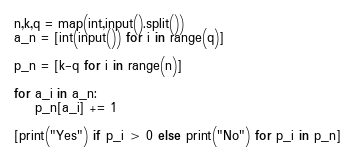<code> <loc_0><loc_0><loc_500><loc_500><_Python_>n,k,q = map(int,input().split())
a_n = [int(input()) for i in range(q)]

p_n = [k-q for i in range(n)]

for a_i in a_n:
    p_n[a_i] += 1

[print("Yes") if p_i > 0 else print("No") for p_i in p_n]
</code> 